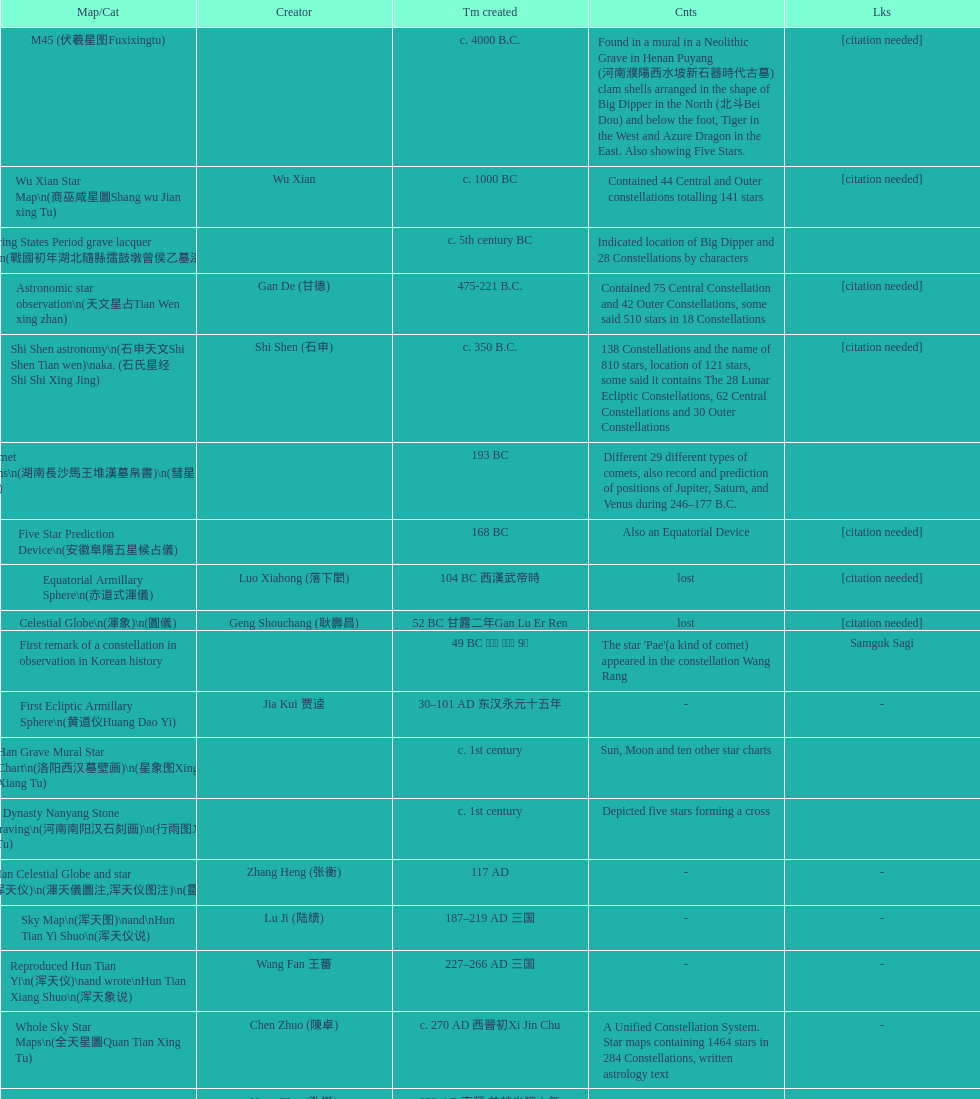Which star map was created earlier, celestial globe or the han grave mural star chart? Celestial Globe. 